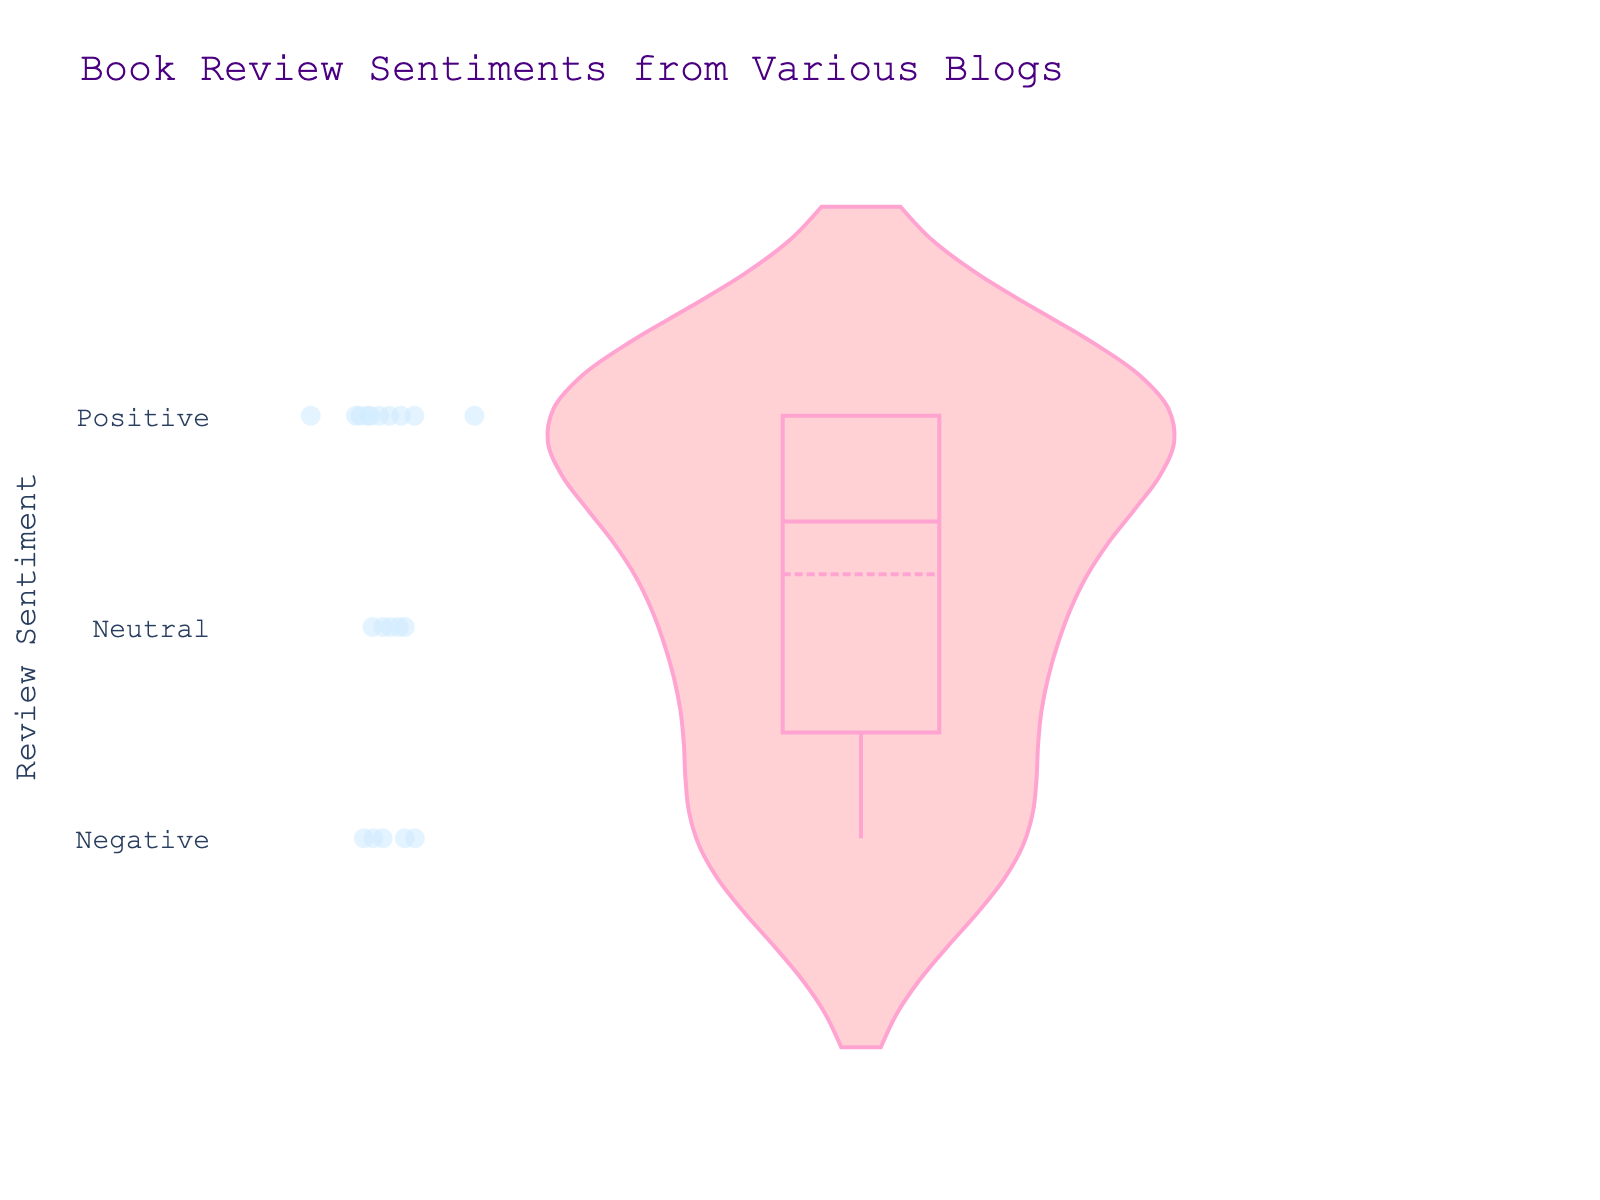What's the title of the figure? The title is usually displayed at the top of the figure. Based on the code provided, we can see that the title specified is "Book Review Sentiments from Various Blogs".
Answer: Book Review Sentiments from Various Blogs What are the labels for the y-axis values? The y-axis represents the sentiment scores, which are mapped from sentiment words to numeric values. According to the code, 0 corresponds to Negative, 1 to Neutral, and 2 to Positive.
Answer: Negative, Neutral, Positive How many distinct sentiment categories are displayed in the dataset? The y-axis tick labels imply three categories: Negative, Neutral, and Positive. These correspond to three distinct sentiment categories.
Answer: 3 Which review sentiment appears to have the most data points in the violin plot? By observing the density and distribution of the points in each y-axis category, the Positive sentiment seems to have the densest area in the violin plot.
Answer: Positive Is there more variation in sentiments marked as Negative, Neutral, or Positive? The width of the violin plot at different sections indicates the variation. By observing, we can see that Negative and Positive have more spread compared to Neutral, indicating more variation.
Answer: Negative and Positive Which review sentiment has the least meanline deviation? A meanline is a visible horizontal line within the violin plot representing the mean of the data. Observing the plot, Neutral sentiments seem to have the meanline closest to the middle of the category range, indicating least deviation.
Answer: Neutral What is the most common sentiment category among book reviews? Observing the amount of data points clustered around each sentiment category, Positive seems to be the most populated.
Answer: Positive How would you describe the distribution of Neutral sentiments compared to Positive sentiments? Neutral sentiments are more tightly clustered around their mean, indicating a smaller spread or less variation, while Positive sentiments show more variation with a wider spread in the violin plot.
Answer: Tightly clustered, smaller spread From observing the plot, do Neutral reviews appear to contain outliers? Since the points display individual data around the main density of the violin plot, Neutral reviews show fewer points away from the central area compared to Positive and Negative, suggesting less or no outliers.
Answer: No significant outliers 